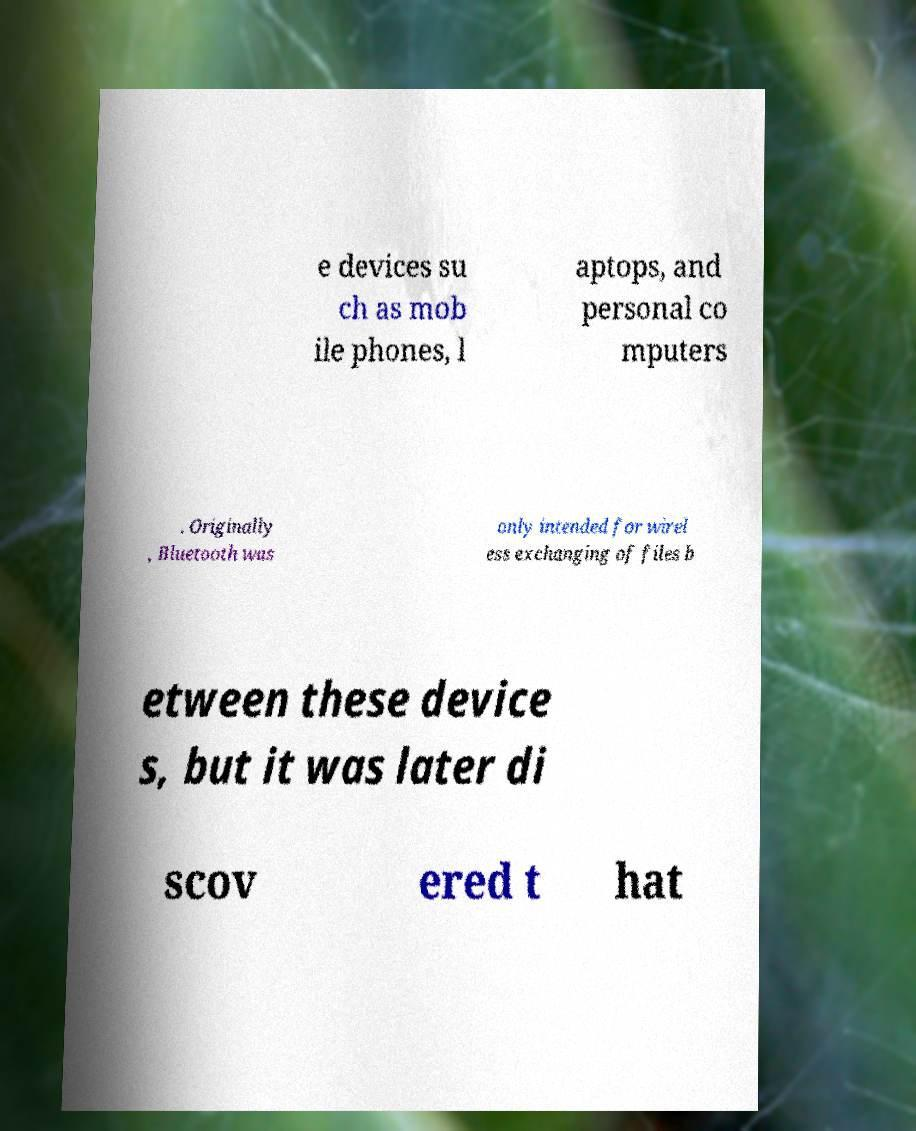Could you assist in decoding the text presented in this image and type it out clearly? e devices su ch as mob ile phones, l aptops, and personal co mputers . Originally , Bluetooth was only intended for wirel ess exchanging of files b etween these device s, but it was later di scov ered t hat 